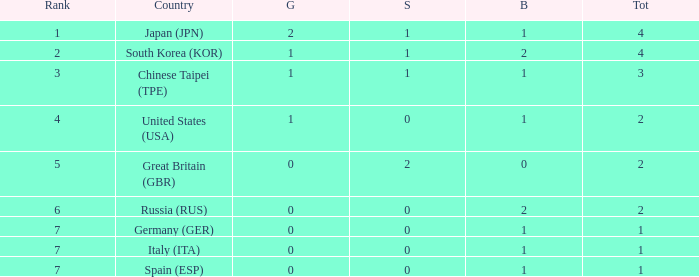What is the smallest number of gold of a country of rank 6, with 2 bronzes? None. 